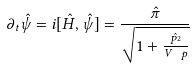<formula> <loc_0><loc_0><loc_500><loc_500>\partial _ { t } \hat { \psi } = i [ \hat { H } , \hat { \psi } ] = \frac { \hat { \pi } } { \sqrt { 1 + \frac { \hat { P ^ { 2 } } } { V _ { \ } p } } }</formula> 